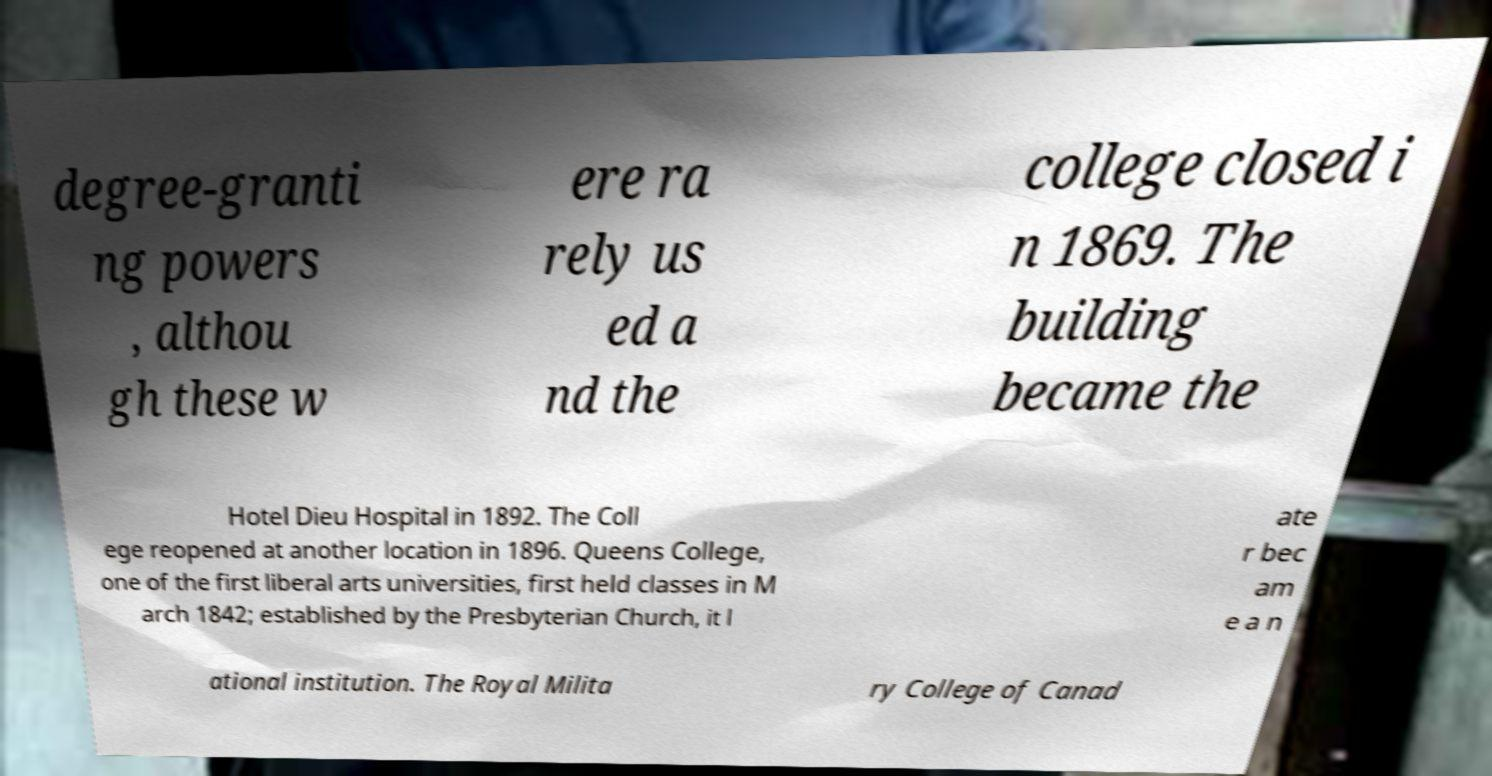There's text embedded in this image that I need extracted. Can you transcribe it verbatim? degree-granti ng powers , althou gh these w ere ra rely us ed a nd the college closed i n 1869. The building became the Hotel Dieu Hospital in 1892. The Coll ege reopened at another location in 1896. Queens College, one of the first liberal arts universities, first held classes in M arch 1842; established by the Presbyterian Church, it l ate r bec am e a n ational institution. The Royal Milita ry College of Canad 